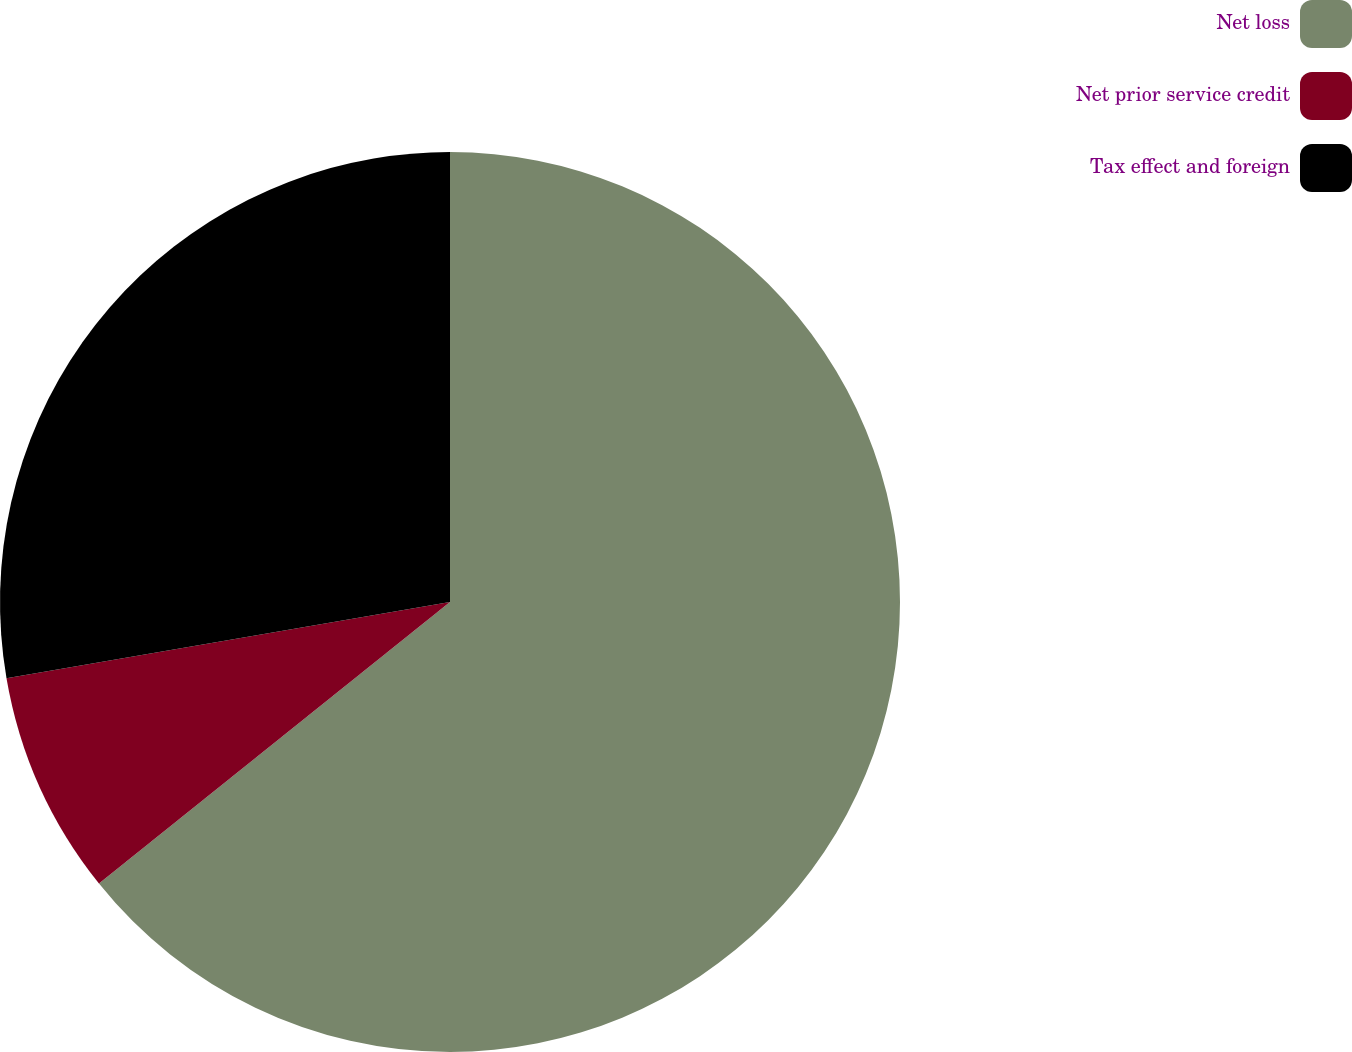Convert chart. <chart><loc_0><loc_0><loc_500><loc_500><pie_chart><fcel>Net loss<fcel>Net prior service credit<fcel>Tax effect and foreign<nl><fcel>64.24%<fcel>8.05%<fcel>27.71%<nl></chart> 